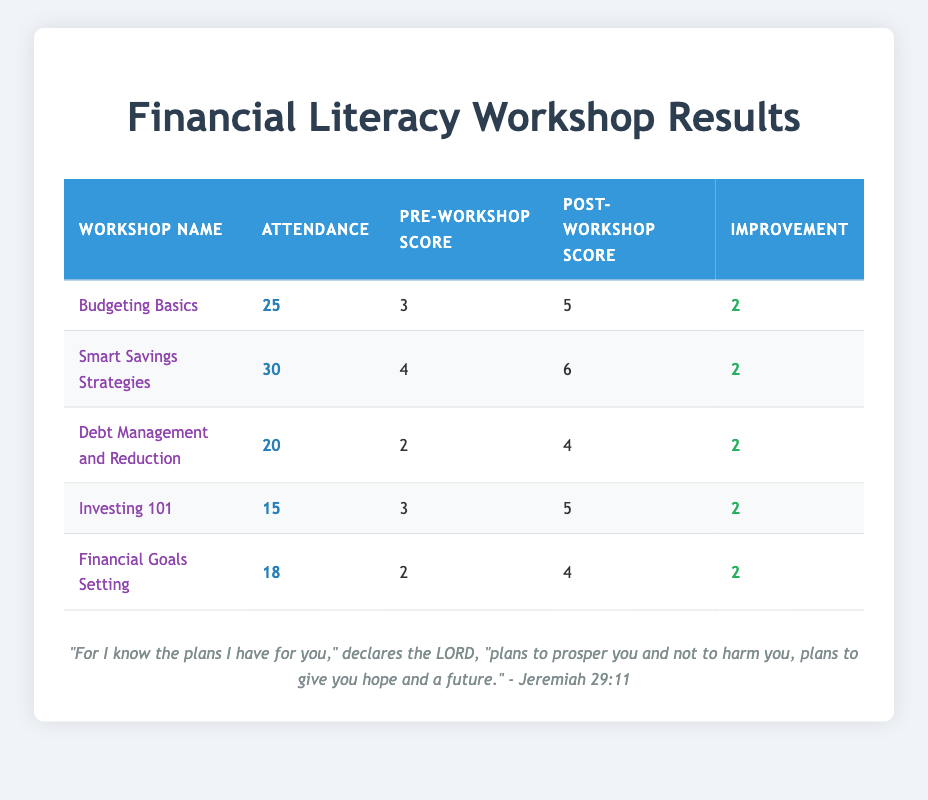What is the attendance for the "Smart Savings Strategies" workshop? The "Smart Savings Strategies" workshop has an attendance of 30 participants, which can be directly found in the "Attendance" column for that specific row in the table.
Answer: 30 Which workshop had the highest pre-workshop budgeting score? To find the highest pre-workshop budgeting score, I compare the values in the "Pre-Workshop Score" column. The maximum score is 4, which belongs to the "Smart Savings Strategies" workshop and "Budgeting Basics".
Answer: Smart Savings Strategies and Budgeting Basics What is the average improvement in budgeting scores across all workshops? The improvements for each workshop are: 2, 2, 2, 2, 2. The sum of improvements is 2 + 2 + 2 + 2 + 2 = 10. Since there are 5 workshops, the average improvement is 10/5 = 2.
Answer: 2 Did any workshops have an attendance of less than 20 participants? By checking the "Attendance" column, the workshops "Debt Management and Reduction" (20), and "Investing 101" (15) can be confirmed. The "Investing 101" workshop had less than 20 participants.
Answer: Yes What is the total attendance of all workshops combined? To find the total attendance, I add up the attendance numbers from the table: 25 + 30 + 20 + 15 + 18 = 138.
Answer: 138 Is there a workshop that did not lead to any improvement in budgeting scores? All workshops listed show an improvement score of 2, indicating that each workshop effectively helped participants improve their budgeting scores. Therefore, there are no workshops that did not lead to improvement.
Answer: No Which workshop had the least improvement in budgeting scores? All workshops show an improvement of 2, so they all have the same improvement value. Therefore, there is no workshop that has less improvement as all improvements are equal.
Answer: None What was the post-workshop budgeting score for the "Financial Goals Setting" workshop? The post-workshop budgeting score for "Financial Goals Setting" is listed in the "Post-Workshop Score" column, which shows a score of 4.
Answer: 4 Which workshop had the lowest pre-workshop budgeting score? The "Debt Management and Reduction" workshop had the lowest pre-workshop budgeting score of 2, when looking through the "Pre-Workshop Score" column.
Answer: Debt Management and Reduction 